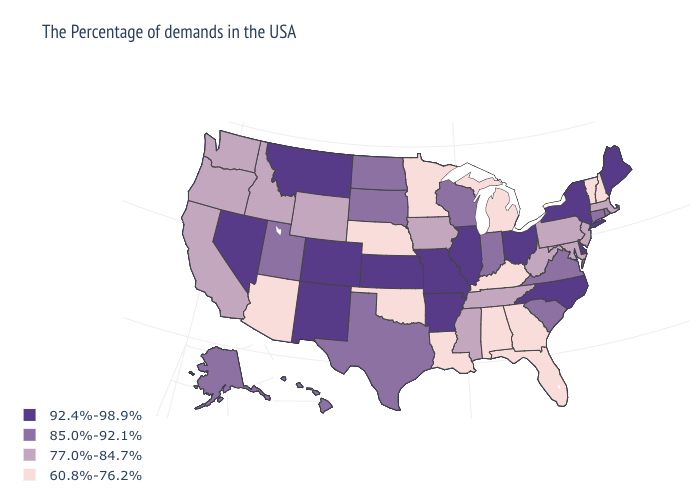Does Montana have the highest value in the USA?
Be succinct. Yes. What is the value of Wyoming?
Write a very short answer. 77.0%-84.7%. What is the highest value in states that border Alabama?
Short answer required. 77.0%-84.7%. Which states have the lowest value in the West?
Keep it brief. Arizona. What is the value of Wisconsin?
Give a very brief answer. 85.0%-92.1%. Name the states that have a value in the range 60.8%-76.2%?
Concise answer only. New Hampshire, Vermont, Florida, Georgia, Michigan, Kentucky, Alabama, Louisiana, Minnesota, Nebraska, Oklahoma, Arizona. Among the states that border Montana , does Wyoming have the highest value?
Give a very brief answer. No. Does Connecticut have the lowest value in the Northeast?
Quick response, please. No. Does the map have missing data?
Be succinct. No. What is the lowest value in states that border Washington?
Short answer required. 77.0%-84.7%. Name the states that have a value in the range 85.0%-92.1%?
Short answer required. Rhode Island, Connecticut, Virginia, South Carolina, Indiana, Wisconsin, Texas, South Dakota, North Dakota, Utah, Alaska, Hawaii. Among the states that border Nebraska , does Wyoming have the lowest value?
Answer briefly. Yes. What is the value of New Mexico?
Keep it brief. 92.4%-98.9%. What is the lowest value in the West?
Short answer required. 60.8%-76.2%. What is the lowest value in the USA?
Be succinct. 60.8%-76.2%. 